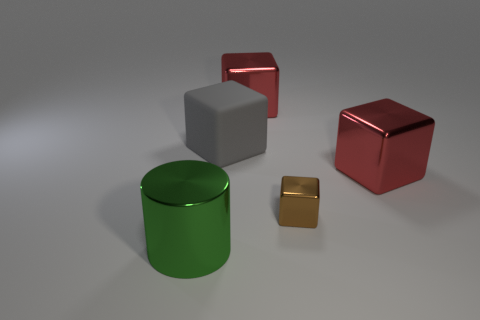Is the number of red things behind the big metallic cylinder greater than the number of tiny purple metal blocks? While I can see several objects in varying colors, there are no tiny purple metal blocks visible in this image. However, there are two red objects behind the green metallic cylinder which suggests that, by default, the number of red things is greater, as we can't compare something to nothing. 